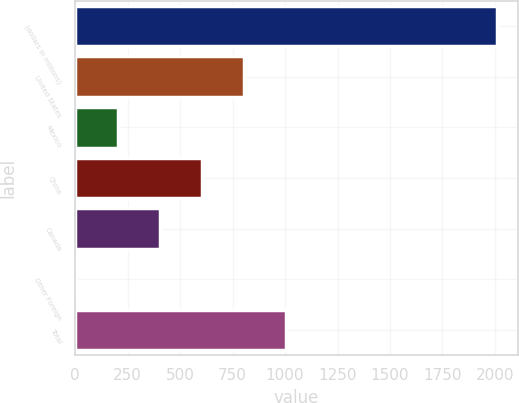Convert chart to OTSL. <chart><loc_0><loc_0><loc_500><loc_500><bar_chart><fcel>(dollars in millions)<fcel>United States<fcel>Mexico<fcel>China<fcel>Canada<fcel>Other Foreign<fcel>Total<nl><fcel>2008<fcel>804.1<fcel>202.15<fcel>603.45<fcel>402.8<fcel>1.5<fcel>1004.75<nl></chart> 